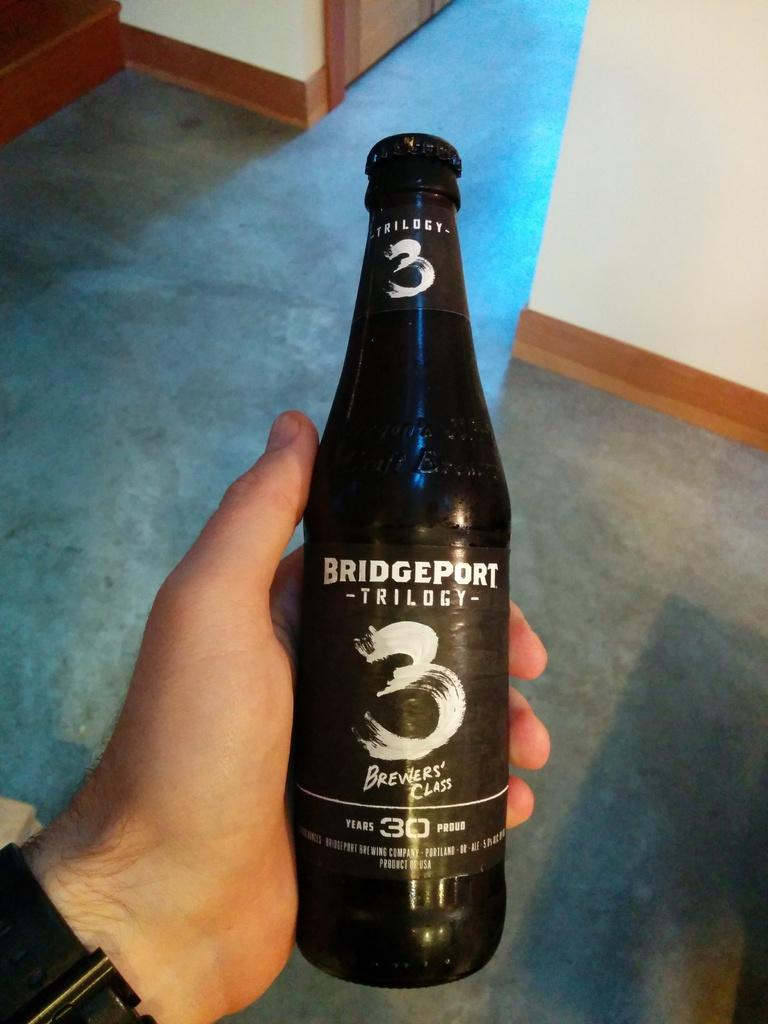What is the person holding in the image? The person is holding a black color bottle. What can be seen in the background of the image? There is a floor and a wall visible in the background of the image. What type of lace can be seen on the person's skirt in the image? There is no skirt or lace present in the image; the person is holding a black color bottle. 